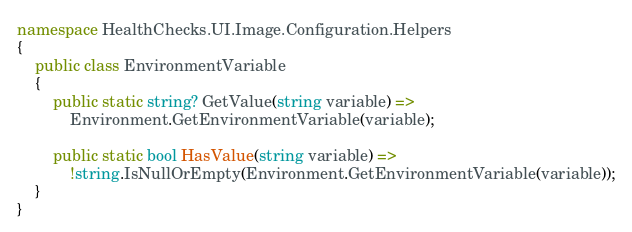<code> <loc_0><loc_0><loc_500><loc_500><_C#_>namespace HealthChecks.UI.Image.Configuration.Helpers
{
    public class EnvironmentVariable
    {
        public static string? GetValue(string variable) =>
            Environment.GetEnvironmentVariable(variable);

        public static bool HasValue(string variable) =>
            !string.IsNullOrEmpty(Environment.GetEnvironmentVariable(variable));
    }
}
</code> 